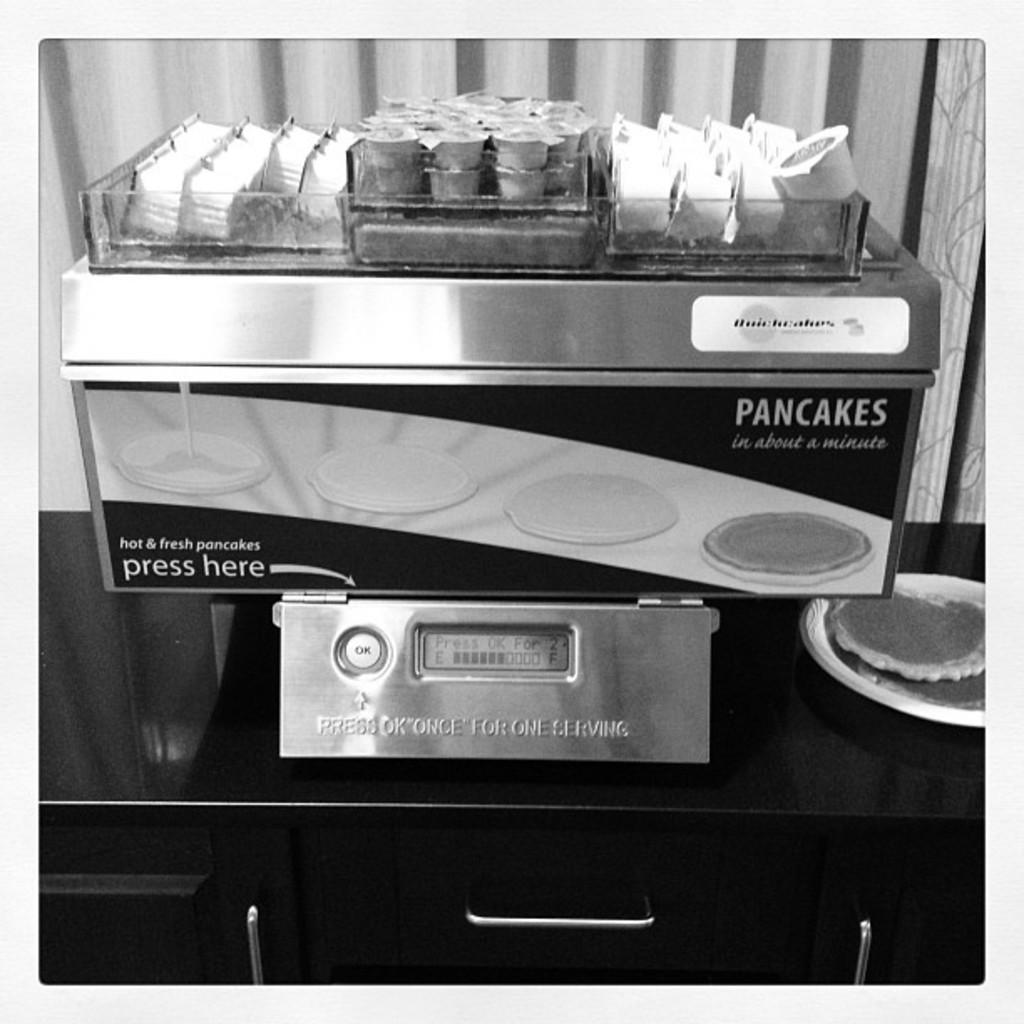<image>
Present a compact description of the photo's key features. The machine makes hot and fresh pancakes in one minute. 